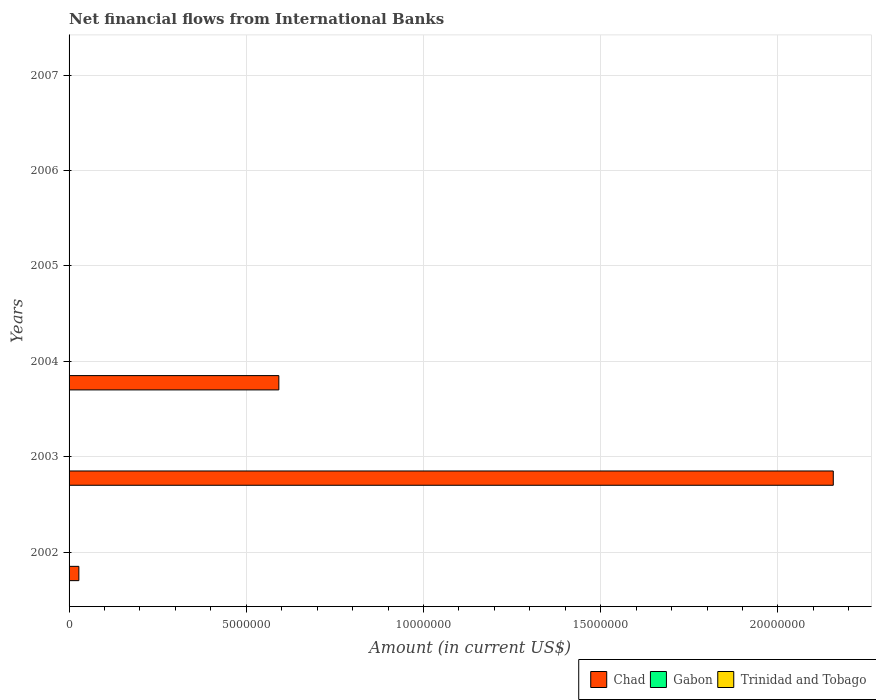Are the number of bars on each tick of the Y-axis equal?
Ensure brevity in your answer.  No. How many bars are there on the 5th tick from the top?
Your answer should be compact. 1. How many bars are there on the 5th tick from the bottom?
Provide a succinct answer. 0. What is the label of the 5th group of bars from the top?
Offer a terse response. 2003. What is the net financial aid flows in Chad in 2006?
Provide a short and direct response. 0. Across all years, what is the maximum net financial aid flows in Chad?
Offer a terse response. 2.16e+07. Across all years, what is the minimum net financial aid flows in Trinidad and Tobago?
Provide a short and direct response. 0. What is the difference between the net financial aid flows in Chad in 2004 and the net financial aid flows in Gabon in 2007?
Your answer should be very brief. 5.92e+06. What is the average net financial aid flows in Chad per year?
Provide a succinct answer. 4.63e+06. What is the ratio of the net financial aid flows in Chad in 2003 to that in 2004?
Offer a terse response. 3.64. What is the difference between the highest and the second highest net financial aid flows in Chad?
Offer a terse response. 1.56e+07. In how many years, is the net financial aid flows in Trinidad and Tobago greater than the average net financial aid flows in Trinidad and Tobago taken over all years?
Your answer should be very brief. 0. Is the sum of the net financial aid flows in Chad in 2002 and 2003 greater than the maximum net financial aid flows in Trinidad and Tobago across all years?
Your response must be concise. Yes. How many years are there in the graph?
Offer a terse response. 6. Are the values on the major ticks of X-axis written in scientific E-notation?
Make the answer very short. No. Where does the legend appear in the graph?
Your answer should be compact. Bottom right. How are the legend labels stacked?
Your answer should be very brief. Horizontal. What is the title of the graph?
Keep it short and to the point. Net financial flows from International Banks. Does "Marshall Islands" appear as one of the legend labels in the graph?
Offer a very short reply. No. What is the Amount (in current US$) in Chad in 2002?
Provide a short and direct response. 2.76e+05. What is the Amount (in current US$) in Trinidad and Tobago in 2002?
Give a very brief answer. 0. What is the Amount (in current US$) in Chad in 2003?
Ensure brevity in your answer.  2.16e+07. What is the Amount (in current US$) of Gabon in 2003?
Keep it short and to the point. 0. What is the Amount (in current US$) of Chad in 2004?
Provide a succinct answer. 5.92e+06. What is the Amount (in current US$) in Gabon in 2004?
Your answer should be compact. 0. What is the Amount (in current US$) in Gabon in 2005?
Keep it short and to the point. 0. What is the Amount (in current US$) in Trinidad and Tobago in 2005?
Give a very brief answer. 0. What is the Amount (in current US$) in Chad in 2006?
Give a very brief answer. 0. What is the Amount (in current US$) in Gabon in 2006?
Offer a very short reply. 0. What is the Amount (in current US$) in Chad in 2007?
Your answer should be very brief. 0. What is the Amount (in current US$) in Gabon in 2007?
Your answer should be compact. 0. Across all years, what is the maximum Amount (in current US$) in Chad?
Your response must be concise. 2.16e+07. Across all years, what is the minimum Amount (in current US$) of Chad?
Ensure brevity in your answer.  0. What is the total Amount (in current US$) in Chad in the graph?
Offer a terse response. 2.78e+07. What is the difference between the Amount (in current US$) in Chad in 2002 and that in 2003?
Offer a very short reply. -2.13e+07. What is the difference between the Amount (in current US$) in Chad in 2002 and that in 2004?
Provide a short and direct response. -5.64e+06. What is the difference between the Amount (in current US$) of Chad in 2003 and that in 2004?
Your answer should be very brief. 1.56e+07. What is the average Amount (in current US$) in Chad per year?
Your answer should be compact. 4.63e+06. What is the ratio of the Amount (in current US$) of Chad in 2002 to that in 2003?
Offer a very short reply. 0.01. What is the ratio of the Amount (in current US$) of Chad in 2002 to that in 2004?
Make the answer very short. 0.05. What is the ratio of the Amount (in current US$) of Chad in 2003 to that in 2004?
Offer a very short reply. 3.64. What is the difference between the highest and the second highest Amount (in current US$) of Chad?
Your answer should be compact. 1.56e+07. What is the difference between the highest and the lowest Amount (in current US$) of Chad?
Give a very brief answer. 2.16e+07. 